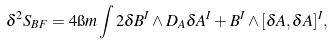Convert formula to latex. <formula><loc_0><loc_0><loc_500><loc_500>\delta ^ { 2 } S _ { B F } = 4 \i m \int 2 \delta B ^ { I } \wedge D _ { A } \delta A ^ { I } + B ^ { I } \wedge [ \delta A , \delta A ] ^ { I } ,</formula> 